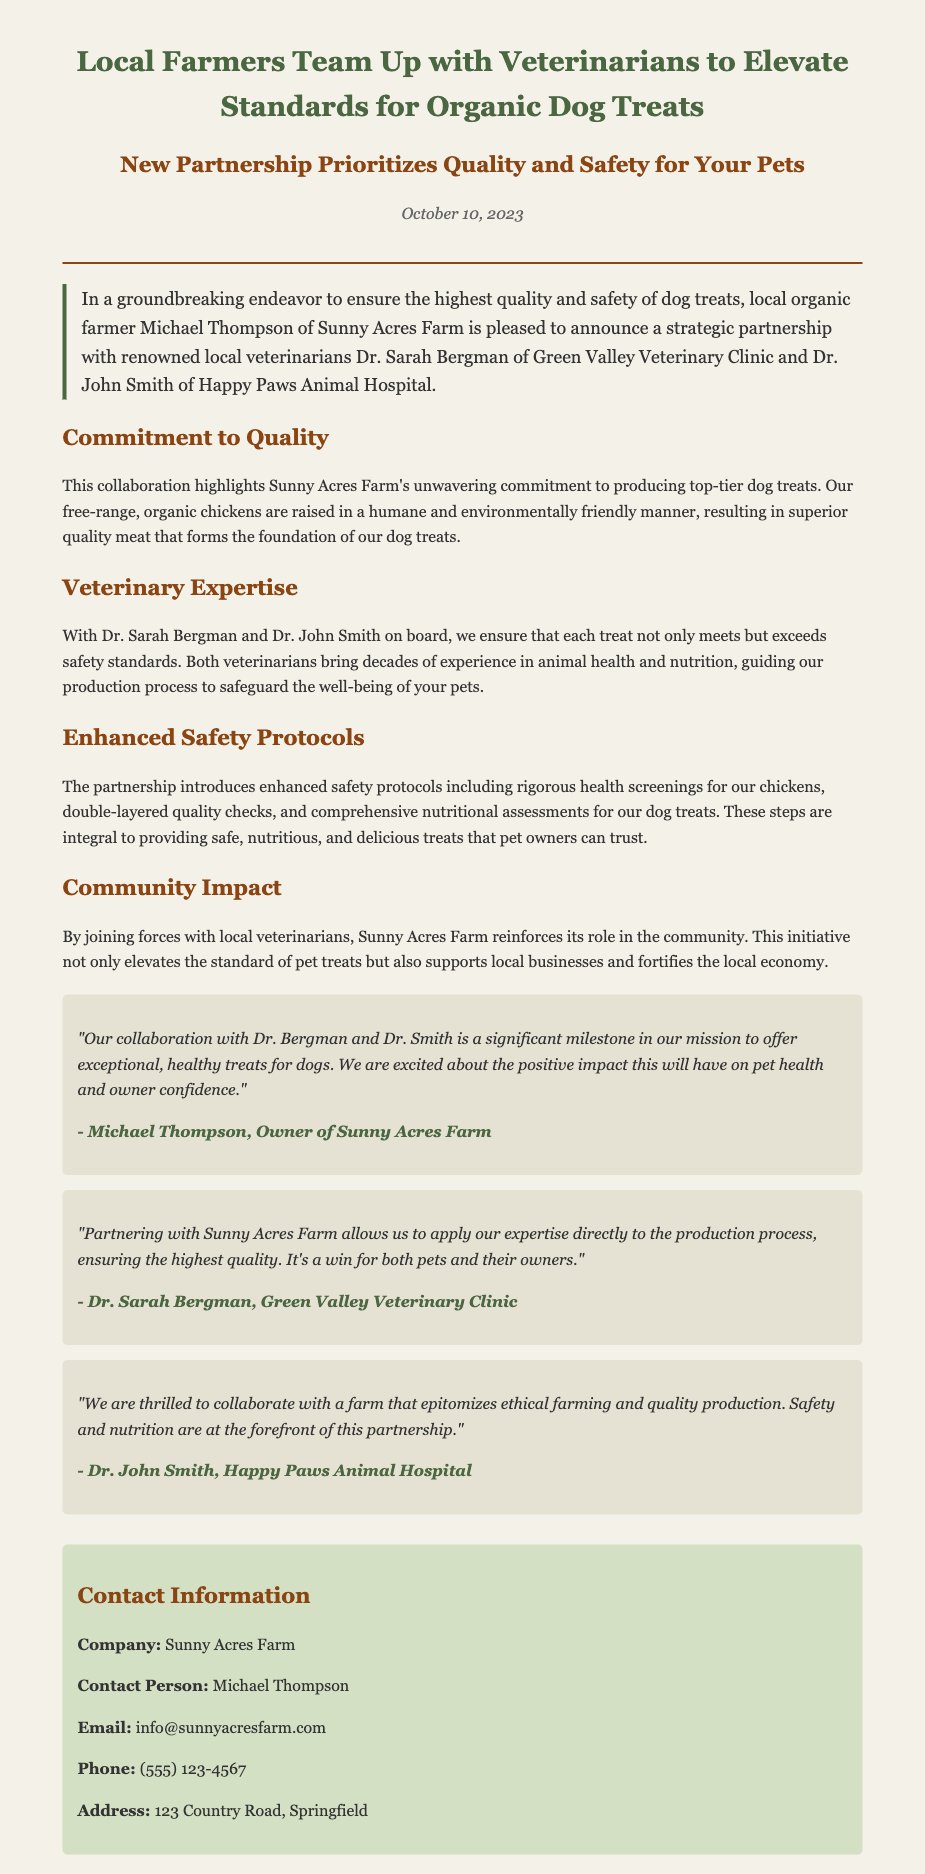what is the title of the press release? The title is usually found at the top of the document, summarizing the main focus of the announcement.
Answer: Local Farmers Team Up with Veterinarians to Elevate Standards for Organic Dog Treats who are the veterinarians involved in the partnership? The veterinarians' names are mentioned in the introduction, which highlights the key individuals in the announcement.
Answer: Dr. Sarah Bergman and Dr. John Smith what is the date of the press release? The date is provided prominently in the date section of the document, indicating when the announcement was made.
Answer: October 10, 2023 what is the primary purpose of the partnership? The document discusses the main goal of the collaboration, which is outlined in the introduction and subsequent sections.
Answer: Ensuring the highest quality and safety for dog treats how do the veterinarians contribute to the partnership? This information can be found in the section that details their roles and the expertise they bring to the collaboration.
Answer: Ensure each treat meets safety standards what is emphasized as a key aspect of the dog treats' production? The document mentions important qualities about the chickens used for the dog treats, showcasing the focus on quality.
Answer: Humane and environmentally friendly raising which community aspect is highlighted in the press release? The document includes a section discussing the impact of the partnership on the local community and economy.
Answer: Supports local businesses and fortifies the local economy what quote is attributed to Michael Thompson? A direct quote provides insight into his perspective on the collaboration and its importance, found in the quotes section.
Answer: "Our collaboration with Dr. Bergman and Dr. Smith is a significant milestone in our mission to offer exceptional, healthy treats for dogs." what enhanced protocols are introduced in the partnership? The document specifies the safety measures implemented due to the partnership, which are listed together in the relevant section.
Answer: Rigorous health screenings for our chickens who is the contact person for inquiries related to the press release? The contact section lists individuals responsible for communication, highlighting who to reach out to for more information.
Answer: Michael Thompson 